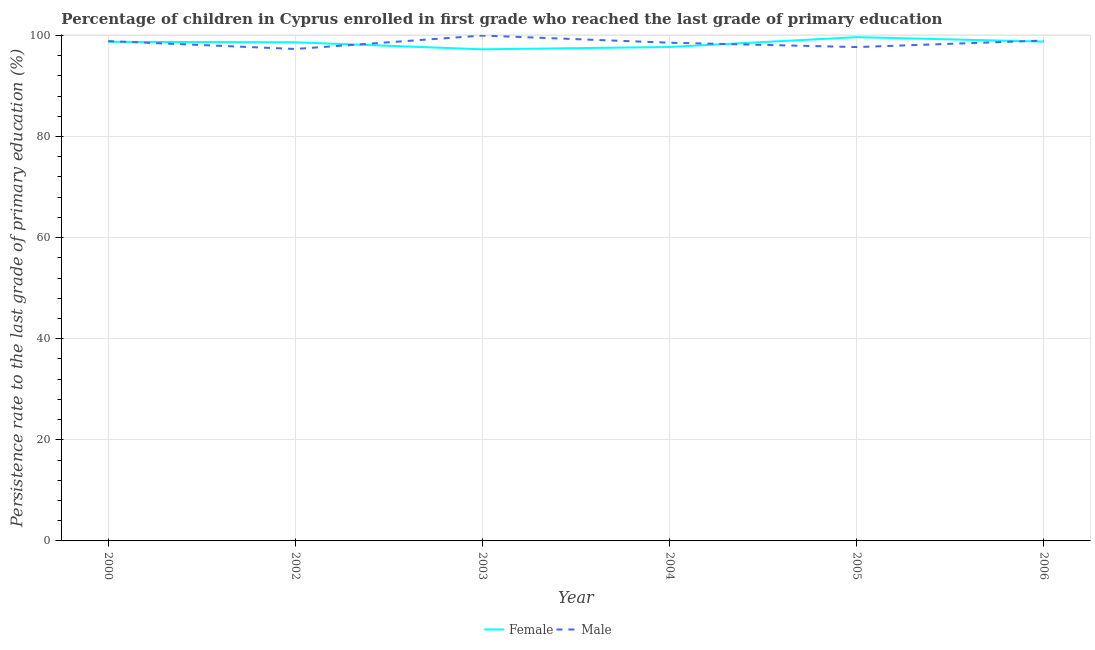How many different coloured lines are there?
Your answer should be very brief. 2. Does the line corresponding to persistence rate of female students intersect with the line corresponding to persistence rate of male students?
Offer a very short reply. Yes. Is the number of lines equal to the number of legend labels?
Provide a succinct answer. Yes. What is the persistence rate of male students in 2003?
Offer a very short reply. 99.97. Across all years, what is the maximum persistence rate of female students?
Offer a terse response. 99.66. Across all years, what is the minimum persistence rate of female students?
Make the answer very short. 97.25. In which year was the persistence rate of male students maximum?
Your answer should be compact. 2003. In which year was the persistence rate of male students minimum?
Your answer should be very brief. 2002. What is the total persistence rate of male students in the graph?
Provide a succinct answer. 591.42. What is the difference between the persistence rate of female students in 2003 and that in 2005?
Keep it short and to the point. -2.41. What is the difference between the persistence rate of male students in 2006 and the persistence rate of female students in 2002?
Your answer should be compact. 0.34. What is the average persistence rate of female students per year?
Your response must be concise. 98.46. In the year 2000, what is the difference between the persistence rate of male students and persistence rate of female students?
Ensure brevity in your answer.  0.14. In how many years, is the persistence rate of female students greater than 20 %?
Offer a very short reply. 6. What is the ratio of the persistence rate of female students in 2004 to that in 2005?
Provide a succinct answer. 0.98. What is the difference between the highest and the second highest persistence rate of female students?
Give a very brief answer. 0.88. What is the difference between the highest and the lowest persistence rate of male students?
Keep it short and to the point. 2.65. In how many years, is the persistence rate of male students greater than the average persistence rate of male students taken over all years?
Your response must be concise. 3. Is the sum of the persistence rate of female students in 2002 and 2006 greater than the maximum persistence rate of male students across all years?
Make the answer very short. Yes. Does the persistence rate of female students monotonically increase over the years?
Offer a terse response. No. Is the persistence rate of female students strictly less than the persistence rate of male students over the years?
Provide a succinct answer. No. How many lines are there?
Provide a short and direct response. 2. How many years are there in the graph?
Make the answer very short. 6. What is the difference between two consecutive major ticks on the Y-axis?
Your response must be concise. 20. Are the values on the major ticks of Y-axis written in scientific E-notation?
Give a very brief answer. No. Does the graph contain any zero values?
Make the answer very short. No. Does the graph contain grids?
Your answer should be compact. Yes. Where does the legend appear in the graph?
Your answer should be very brief. Bottom center. How many legend labels are there?
Your answer should be very brief. 2. How are the legend labels stacked?
Keep it short and to the point. Horizontal. What is the title of the graph?
Give a very brief answer. Percentage of children in Cyprus enrolled in first grade who reached the last grade of primary education. Does "Private creditors" appear as one of the legend labels in the graph?
Your answer should be very brief. No. What is the label or title of the X-axis?
Keep it short and to the point. Year. What is the label or title of the Y-axis?
Offer a very short reply. Persistence rate to the last grade of primary education (%). What is the Persistence rate to the last grade of primary education (%) of Female in 2000?
Give a very brief answer. 98.74. What is the Persistence rate to the last grade of primary education (%) in Male in 2000?
Provide a succinct answer. 98.88. What is the Persistence rate to the last grade of primary education (%) in Female in 2002?
Make the answer very short. 98.64. What is the Persistence rate to the last grade of primary education (%) in Male in 2002?
Offer a very short reply. 97.32. What is the Persistence rate to the last grade of primary education (%) in Female in 2003?
Keep it short and to the point. 97.25. What is the Persistence rate to the last grade of primary education (%) in Male in 2003?
Your response must be concise. 99.97. What is the Persistence rate to the last grade of primary education (%) in Female in 2004?
Your answer should be compact. 97.71. What is the Persistence rate to the last grade of primary education (%) in Male in 2004?
Your response must be concise. 98.56. What is the Persistence rate to the last grade of primary education (%) of Female in 2005?
Your answer should be compact. 99.66. What is the Persistence rate to the last grade of primary education (%) in Male in 2005?
Provide a succinct answer. 97.7. What is the Persistence rate to the last grade of primary education (%) of Female in 2006?
Offer a very short reply. 98.78. What is the Persistence rate to the last grade of primary education (%) in Male in 2006?
Make the answer very short. 98.99. Across all years, what is the maximum Persistence rate to the last grade of primary education (%) of Female?
Make the answer very short. 99.66. Across all years, what is the maximum Persistence rate to the last grade of primary education (%) of Male?
Give a very brief answer. 99.97. Across all years, what is the minimum Persistence rate to the last grade of primary education (%) in Female?
Provide a short and direct response. 97.25. Across all years, what is the minimum Persistence rate to the last grade of primary education (%) in Male?
Your response must be concise. 97.32. What is the total Persistence rate to the last grade of primary education (%) in Female in the graph?
Your answer should be very brief. 590.79. What is the total Persistence rate to the last grade of primary education (%) in Male in the graph?
Your answer should be compact. 591.42. What is the difference between the Persistence rate to the last grade of primary education (%) of Female in 2000 and that in 2002?
Offer a terse response. 0.09. What is the difference between the Persistence rate to the last grade of primary education (%) of Male in 2000 and that in 2002?
Provide a succinct answer. 1.55. What is the difference between the Persistence rate to the last grade of primary education (%) of Female in 2000 and that in 2003?
Offer a very short reply. 1.48. What is the difference between the Persistence rate to the last grade of primary education (%) of Male in 2000 and that in 2003?
Keep it short and to the point. -1.1. What is the difference between the Persistence rate to the last grade of primary education (%) in Female in 2000 and that in 2004?
Your answer should be compact. 1.02. What is the difference between the Persistence rate to the last grade of primary education (%) of Male in 2000 and that in 2004?
Ensure brevity in your answer.  0.32. What is the difference between the Persistence rate to the last grade of primary education (%) in Female in 2000 and that in 2005?
Your response must be concise. -0.92. What is the difference between the Persistence rate to the last grade of primary education (%) of Male in 2000 and that in 2005?
Your response must be concise. 1.18. What is the difference between the Persistence rate to the last grade of primary education (%) of Female in 2000 and that in 2006?
Your answer should be compact. -0.04. What is the difference between the Persistence rate to the last grade of primary education (%) of Male in 2000 and that in 2006?
Offer a very short reply. -0.11. What is the difference between the Persistence rate to the last grade of primary education (%) of Female in 2002 and that in 2003?
Provide a succinct answer. 1.39. What is the difference between the Persistence rate to the last grade of primary education (%) in Male in 2002 and that in 2003?
Provide a succinct answer. -2.65. What is the difference between the Persistence rate to the last grade of primary education (%) of Female in 2002 and that in 2004?
Give a very brief answer. 0.93. What is the difference between the Persistence rate to the last grade of primary education (%) of Male in 2002 and that in 2004?
Your answer should be compact. -1.24. What is the difference between the Persistence rate to the last grade of primary education (%) in Female in 2002 and that in 2005?
Ensure brevity in your answer.  -1.01. What is the difference between the Persistence rate to the last grade of primary education (%) of Male in 2002 and that in 2005?
Give a very brief answer. -0.38. What is the difference between the Persistence rate to the last grade of primary education (%) in Female in 2002 and that in 2006?
Your answer should be very brief. -0.13. What is the difference between the Persistence rate to the last grade of primary education (%) in Male in 2002 and that in 2006?
Give a very brief answer. -1.66. What is the difference between the Persistence rate to the last grade of primary education (%) in Female in 2003 and that in 2004?
Make the answer very short. -0.46. What is the difference between the Persistence rate to the last grade of primary education (%) in Male in 2003 and that in 2004?
Offer a very short reply. 1.41. What is the difference between the Persistence rate to the last grade of primary education (%) of Female in 2003 and that in 2005?
Keep it short and to the point. -2.41. What is the difference between the Persistence rate to the last grade of primary education (%) of Male in 2003 and that in 2005?
Provide a succinct answer. 2.28. What is the difference between the Persistence rate to the last grade of primary education (%) in Female in 2003 and that in 2006?
Provide a short and direct response. -1.52. What is the difference between the Persistence rate to the last grade of primary education (%) of Female in 2004 and that in 2005?
Offer a very short reply. -1.95. What is the difference between the Persistence rate to the last grade of primary education (%) of Male in 2004 and that in 2005?
Your answer should be very brief. 0.86. What is the difference between the Persistence rate to the last grade of primary education (%) in Female in 2004 and that in 2006?
Give a very brief answer. -1.06. What is the difference between the Persistence rate to the last grade of primary education (%) in Male in 2004 and that in 2006?
Make the answer very short. -0.43. What is the difference between the Persistence rate to the last grade of primary education (%) of Female in 2005 and that in 2006?
Your answer should be compact. 0.88. What is the difference between the Persistence rate to the last grade of primary education (%) in Male in 2005 and that in 2006?
Your answer should be very brief. -1.29. What is the difference between the Persistence rate to the last grade of primary education (%) of Female in 2000 and the Persistence rate to the last grade of primary education (%) of Male in 2002?
Give a very brief answer. 1.42. What is the difference between the Persistence rate to the last grade of primary education (%) of Female in 2000 and the Persistence rate to the last grade of primary education (%) of Male in 2003?
Ensure brevity in your answer.  -1.24. What is the difference between the Persistence rate to the last grade of primary education (%) in Female in 2000 and the Persistence rate to the last grade of primary education (%) in Male in 2004?
Provide a short and direct response. 0.18. What is the difference between the Persistence rate to the last grade of primary education (%) of Female in 2000 and the Persistence rate to the last grade of primary education (%) of Male in 2005?
Provide a succinct answer. 1.04. What is the difference between the Persistence rate to the last grade of primary education (%) in Female in 2000 and the Persistence rate to the last grade of primary education (%) in Male in 2006?
Your response must be concise. -0.25. What is the difference between the Persistence rate to the last grade of primary education (%) of Female in 2002 and the Persistence rate to the last grade of primary education (%) of Male in 2003?
Give a very brief answer. -1.33. What is the difference between the Persistence rate to the last grade of primary education (%) of Female in 2002 and the Persistence rate to the last grade of primary education (%) of Male in 2004?
Provide a short and direct response. 0.08. What is the difference between the Persistence rate to the last grade of primary education (%) of Female in 2002 and the Persistence rate to the last grade of primary education (%) of Male in 2005?
Your response must be concise. 0.95. What is the difference between the Persistence rate to the last grade of primary education (%) in Female in 2002 and the Persistence rate to the last grade of primary education (%) in Male in 2006?
Your answer should be compact. -0.34. What is the difference between the Persistence rate to the last grade of primary education (%) in Female in 2003 and the Persistence rate to the last grade of primary education (%) in Male in 2004?
Offer a very short reply. -1.31. What is the difference between the Persistence rate to the last grade of primary education (%) in Female in 2003 and the Persistence rate to the last grade of primary education (%) in Male in 2005?
Make the answer very short. -0.45. What is the difference between the Persistence rate to the last grade of primary education (%) in Female in 2003 and the Persistence rate to the last grade of primary education (%) in Male in 2006?
Offer a terse response. -1.73. What is the difference between the Persistence rate to the last grade of primary education (%) in Female in 2004 and the Persistence rate to the last grade of primary education (%) in Male in 2005?
Offer a terse response. 0.01. What is the difference between the Persistence rate to the last grade of primary education (%) of Female in 2004 and the Persistence rate to the last grade of primary education (%) of Male in 2006?
Make the answer very short. -1.27. What is the difference between the Persistence rate to the last grade of primary education (%) in Female in 2005 and the Persistence rate to the last grade of primary education (%) in Male in 2006?
Ensure brevity in your answer.  0.67. What is the average Persistence rate to the last grade of primary education (%) of Female per year?
Ensure brevity in your answer.  98.46. What is the average Persistence rate to the last grade of primary education (%) in Male per year?
Your answer should be very brief. 98.57. In the year 2000, what is the difference between the Persistence rate to the last grade of primary education (%) of Female and Persistence rate to the last grade of primary education (%) of Male?
Offer a very short reply. -0.14. In the year 2002, what is the difference between the Persistence rate to the last grade of primary education (%) in Female and Persistence rate to the last grade of primary education (%) in Male?
Make the answer very short. 1.32. In the year 2003, what is the difference between the Persistence rate to the last grade of primary education (%) of Female and Persistence rate to the last grade of primary education (%) of Male?
Offer a terse response. -2.72. In the year 2004, what is the difference between the Persistence rate to the last grade of primary education (%) of Female and Persistence rate to the last grade of primary education (%) of Male?
Provide a succinct answer. -0.85. In the year 2005, what is the difference between the Persistence rate to the last grade of primary education (%) of Female and Persistence rate to the last grade of primary education (%) of Male?
Ensure brevity in your answer.  1.96. In the year 2006, what is the difference between the Persistence rate to the last grade of primary education (%) in Female and Persistence rate to the last grade of primary education (%) in Male?
Your response must be concise. -0.21. What is the ratio of the Persistence rate to the last grade of primary education (%) of Female in 2000 to that in 2002?
Offer a very short reply. 1. What is the ratio of the Persistence rate to the last grade of primary education (%) of Female in 2000 to that in 2003?
Your answer should be very brief. 1.02. What is the ratio of the Persistence rate to the last grade of primary education (%) in Female in 2000 to that in 2004?
Your answer should be compact. 1.01. What is the ratio of the Persistence rate to the last grade of primary education (%) of Male in 2000 to that in 2005?
Your answer should be compact. 1.01. What is the ratio of the Persistence rate to the last grade of primary education (%) in Male in 2000 to that in 2006?
Your answer should be compact. 1. What is the ratio of the Persistence rate to the last grade of primary education (%) in Female in 2002 to that in 2003?
Provide a short and direct response. 1.01. What is the ratio of the Persistence rate to the last grade of primary education (%) of Male in 2002 to that in 2003?
Provide a short and direct response. 0.97. What is the ratio of the Persistence rate to the last grade of primary education (%) of Female in 2002 to that in 2004?
Keep it short and to the point. 1.01. What is the ratio of the Persistence rate to the last grade of primary education (%) of Male in 2002 to that in 2004?
Provide a short and direct response. 0.99. What is the ratio of the Persistence rate to the last grade of primary education (%) of Female in 2002 to that in 2005?
Make the answer very short. 0.99. What is the ratio of the Persistence rate to the last grade of primary education (%) in Female in 2002 to that in 2006?
Offer a terse response. 1. What is the ratio of the Persistence rate to the last grade of primary education (%) in Male in 2002 to that in 2006?
Give a very brief answer. 0.98. What is the ratio of the Persistence rate to the last grade of primary education (%) of Male in 2003 to that in 2004?
Keep it short and to the point. 1.01. What is the ratio of the Persistence rate to the last grade of primary education (%) in Female in 2003 to that in 2005?
Provide a short and direct response. 0.98. What is the ratio of the Persistence rate to the last grade of primary education (%) in Male in 2003 to that in 2005?
Keep it short and to the point. 1.02. What is the ratio of the Persistence rate to the last grade of primary education (%) of Female in 2003 to that in 2006?
Provide a succinct answer. 0.98. What is the ratio of the Persistence rate to the last grade of primary education (%) of Female in 2004 to that in 2005?
Ensure brevity in your answer.  0.98. What is the ratio of the Persistence rate to the last grade of primary education (%) of Male in 2004 to that in 2005?
Make the answer very short. 1.01. What is the ratio of the Persistence rate to the last grade of primary education (%) of Female in 2004 to that in 2006?
Provide a short and direct response. 0.99. What is the ratio of the Persistence rate to the last grade of primary education (%) of Male in 2004 to that in 2006?
Your answer should be very brief. 1. What is the ratio of the Persistence rate to the last grade of primary education (%) in Female in 2005 to that in 2006?
Ensure brevity in your answer.  1.01. What is the difference between the highest and the second highest Persistence rate to the last grade of primary education (%) of Female?
Provide a short and direct response. 0.88. What is the difference between the highest and the second highest Persistence rate to the last grade of primary education (%) in Male?
Your answer should be very brief. 0.99. What is the difference between the highest and the lowest Persistence rate to the last grade of primary education (%) of Female?
Your answer should be very brief. 2.41. What is the difference between the highest and the lowest Persistence rate to the last grade of primary education (%) of Male?
Make the answer very short. 2.65. 